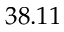Convert formula to latex. <formula><loc_0><loc_0><loc_500><loc_500>3 8 . 1 1</formula> 